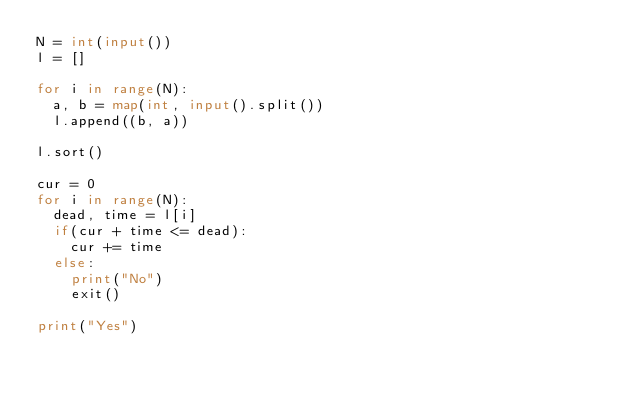<code> <loc_0><loc_0><loc_500><loc_500><_Python_>N = int(input())
l = []
    
for i in range(N):
  a, b = map(int, input().split())
  l.append((b, a))
  
l.sort()

cur = 0
for i in range(N):
  dead, time = l[i]
  if(cur + time <= dead):
    cur += time
  else:
    print("No")
    exit()

print("Yes")</code> 